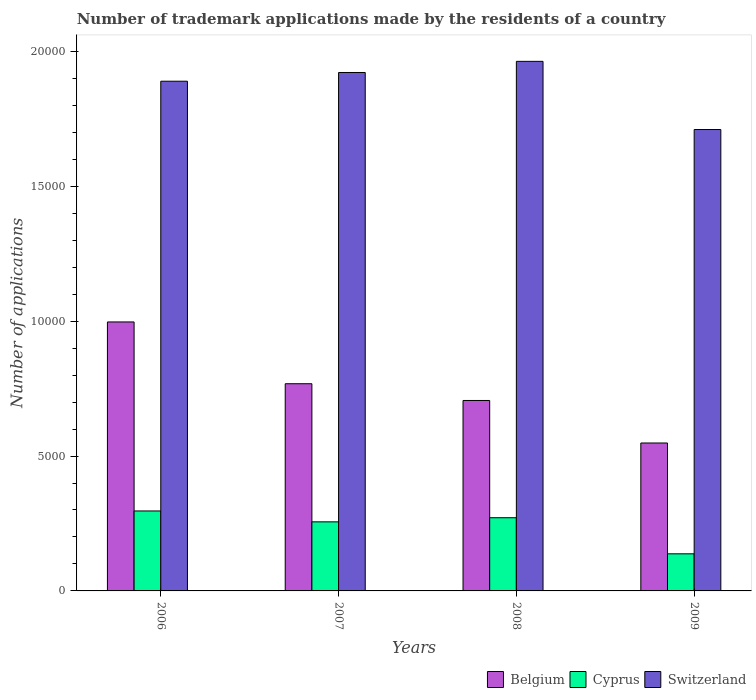How many groups of bars are there?
Your answer should be compact. 4. What is the label of the 2nd group of bars from the left?
Your answer should be compact. 2007. In how many cases, is the number of bars for a given year not equal to the number of legend labels?
Your response must be concise. 0. What is the number of trademark applications made by the residents in Switzerland in 2006?
Offer a very short reply. 1.89e+04. Across all years, what is the maximum number of trademark applications made by the residents in Cyprus?
Keep it short and to the point. 2964. Across all years, what is the minimum number of trademark applications made by the residents in Cyprus?
Give a very brief answer. 1375. What is the total number of trademark applications made by the residents in Switzerland in the graph?
Your answer should be compact. 7.48e+04. What is the difference between the number of trademark applications made by the residents in Belgium in 2008 and that in 2009?
Offer a very short reply. 1576. What is the difference between the number of trademark applications made by the residents in Cyprus in 2008 and the number of trademark applications made by the residents in Switzerland in 2006?
Your answer should be very brief. -1.62e+04. What is the average number of trademark applications made by the residents in Cyprus per year?
Keep it short and to the point. 2403. In the year 2006, what is the difference between the number of trademark applications made by the residents in Cyprus and number of trademark applications made by the residents in Belgium?
Offer a terse response. -7006. In how many years, is the number of trademark applications made by the residents in Switzerland greater than 7000?
Provide a succinct answer. 4. What is the ratio of the number of trademark applications made by the residents in Switzerland in 2006 to that in 2007?
Your answer should be very brief. 0.98. Is the number of trademark applications made by the residents in Switzerland in 2008 less than that in 2009?
Your answer should be compact. No. Is the difference between the number of trademark applications made by the residents in Cyprus in 2008 and 2009 greater than the difference between the number of trademark applications made by the residents in Belgium in 2008 and 2009?
Make the answer very short. No. What is the difference between the highest and the second highest number of trademark applications made by the residents in Belgium?
Give a very brief answer. 2290. What is the difference between the highest and the lowest number of trademark applications made by the residents in Switzerland?
Provide a short and direct response. 2527. Is the sum of the number of trademark applications made by the residents in Switzerland in 2008 and 2009 greater than the maximum number of trademark applications made by the residents in Cyprus across all years?
Offer a very short reply. Yes. What does the 2nd bar from the left in 2009 represents?
Offer a terse response. Cyprus. Is it the case that in every year, the sum of the number of trademark applications made by the residents in Switzerland and number of trademark applications made by the residents in Cyprus is greater than the number of trademark applications made by the residents in Belgium?
Offer a terse response. Yes. How many bars are there?
Provide a short and direct response. 12. Are all the bars in the graph horizontal?
Provide a short and direct response. No. What is the difference between two consecutive major ticks on the Y-axis?
Keep it short and to the point. 5000. Does the graph contain any zero values?
Offer a terse response. No. Where does the legend appear in the graph?
Keep it short and to the point. Bottom right. What is the title of the graph?
Give a very brief answer. Number of trademark applications made by the residents of a country. What is the label or title of the Y-axis?
Ensure brevity in your answer.  Number of applications. What is the Number of applications of Belgium in 2006?
Keep it short and to the point. 9970. What is the Number of applications in Cyprus in 2006?
Ensure brevity in your answer.  2964. What is the Number of applications of Switzerland in 2006?
Ensure brevity in your answer.  1.89e+04. What is the Number of applications in Belgium in 2007?
Make the answer very short. 7680. What is the Number of applications in Cyprus in 2007?
Your response must be concise. 2560. What is the Number of applications of Switzerland in 2007?
Ensure brevity in your answer.  1.92e+04. What is the Number of applications of Belgium in 2008?
Make the answer very short. 7059. What is the Number of applications of Cyprus in 2008?
Offer a terse response. 2713. What is the Number of applications in Switzerland in 2008?
Provide a succinct answer. 1.96e+04. What is the Number of applications of Belgium in 2009?
Your response must be concise. 5483. What is the Number of applications in Cyprus in 2009?
Offer a very short reply. 1375. What is the Number of applications of Switzerland in 2009?
Offer a terse response. 1.71e+04. Across all years, what is the maximum Number of applications of Belgium?
Your answer should be very brief. 9970. Across all years, what is the maximum Number of applications of Cyprus?
Give a very brief answer. 2964. Across all years, what is the maximum Number of applications of Switzerland?
Ensure brevity in your answer.  1.96e+04. Across all years, what is the minimum Number of applications in Belgium?
Ensure brevity in your answer.  5483. Across all years, what is the minimum Number of applications in Cyprus?
Offer a terse response. 1375. Across all years, what is the minimum Number of applications in Switzerland?
Make the answer very short. 1.71e+04. What is the total Number of applications in Belgium in the graph?
Your answer should be very brief. 3.02e+04. What is the total Number of applications in Cyprus in the graph?
Ensure brevity in your answer.  9612. What is the total Number of applications in Switzerland in the graph?
Provide a succinct answer. 7.48e+04. What is the difference between the Number of applications in Belgium in 2006 and that in 2007?
Ensure brevity in your answer.  2290. What is the difference between the Number of applications of Cyprus in 2006 and that in 2007?
Keep it short and to the point. 404. What is the difference between the Number of applications in Switzerland in 2006 and that in 2007?
Provide a succinct answer. -323. What is the difference between the Number of applications in Belgium in 2006 and that in 2008?
Your answer should be very brief. 2911. What is the difference between the Number of applications in Cyprus in 2006 and that in 2008?
Offer a very short reply. 251. What is the difference between the Number of applications of Switzerland in 2006 and that in 2008?
Offer a terse response. -736. What is the difference between the Number of applications of Belgium in 2006 and that in 2009?
Provide a succinct answer. 4487. What is the difference between the Number of applications of Cyprus in 2006 and that in 2009?
Ensure brevity in your answer.  1589. What is the difference between the Number of applications of Switzerland in 2006 and that in 2009?
Offer a very short reply. 1791. What is the difference between the Number of applications of Belgium in 2007 and that in 2008?
Provide a succinct answer. 621. What is the difference between the Number of applications in Cyprus in 2007 and that in 2008?
Ensure brevity in your answer.  -153. What is the difference between the Number of applications in Switzerland in 2007 and that in 2008?
Make the answer very short. -413. What is the difference between the Number of applications in Belgium in 2007 and that in 2009?
Give a very brief answer. 2197. What is the difference between the Number of applications in Cyprus in 2007 and that in 2009?
Your response must be concise. 1185. What is the difference between the Number of applications in Switzerland in 2007 and that in 2009?
Offer a terse response. 2114. What is the difference between the Number of applications of Belgium in 2008 and that in 2009?
Provide a short and direct response. 1576. What is the difference between the Number of applications of Cyprus in 2008 and that in 2009?
Your response must be concise. 1338. What is the difference between the Number of applications in Switzerland in 2008 and that in 2009?
Your response must be concise. 2527. What is the difference between the Number of applications of Belgium in 2006 and the Number of applications of Cyprus in 2007?
Your answer should be very brief. 7410. What is the difference between the Number of applications in Belgium in 2006 and the Number of applications in Switzerland in 2007?
Offer a very short reply. -9246. What is the difference between the Number of applications in Cyprus in 2006 and the Number of applications in Switzerland in 2007?
Your answer should be very brief. -1.63e+04. What is the difference between the Number of applications in Belgium in 2006 and the Number of applications in Cyprus in 2008?
Keep it short and to the point. 7257. What is the difference between the Number of applications in Belgium in 2006 and the Number of applications in Switzerland in 2008?
Keep it short and to the point. -9659. What is the difference between the Number of applications of Cyprus in 2006 and the Number of applications of Switzerland in 2008?
Offer a very short reply. -1.67e+04. What is the difference between the Number of applications in Belgium in 2006 and the Number of applications in Cyprus in 2009?
Your answer should be compact. 8595. What is the difference between the Number of applications of Belgium in 2006 and the Number of applications of Switzerland in 2009?
Offer a terse response. -7132. What is the difference between the Number of applications in Cyprus in 2006 and the Number of applications in Switzerland in 2009?
Offer a very short reply. -1.41e+04. What is the difference between the Number of applications of Belgium in 2007 and the Number of applications of Cyprus in 2008?
Your answer should be compact. 4967. What is the difference between the Number of applications in Belgium in 2007 and the Number of applications in Switzerland in 2008?
Make the answer very short. -1.19e+04. What is the difference between the Number of applications of Cyprus in 2007 and the Number of applications of Switzerland in 2008?
Keep it short and to the point. -1.71e+04. What is the difference between the Number of applications in Belgium in 2007 and the Number of applications in Cyprus in 2009?
Make the answer very short. 6305. What is the difference between the Number of applications of Belgium in 2007 and the Number of applications of Switzerland in 2009?
Provide a succinct answer. -9422. What is the difference between the Number of applications of Cyprus in 2007 and the Number of applications of Switzerland in 2009?
Your answer should be compact. -1.45e+04. What is the difference between the Number of applications in Belgium in 2008 and the Number of applications in Cyprus in 2009?
Give a very brief answer. 5684. What is the difference between the Number of applications in Belgium in 2008 and the Number of applications in Switzerland in 2009?
Offer a very short reply. -1.00e+04. What is the difference between the Number of applications in Cyprus in 2008 and the Number of applications in Switzerland in 2009?
Offer a very short reply. -1.44e+04. What is the average Number of applications of Belgium per year?
Your response must be concise. 7548. What is the average Number of applications of Cyprus per year?
Provide a succinct answer. 2403. What is the average Number of applications of Switzerland per year?
Your response must be concise. 1.87e+04. In the year 2006, what is the difference between the Number of applications of Belgium and Number of applications of Cyprus?
Offer a very short reply. 7006. In the year 2006, what is the difference between the Number of applications in Belgium and Number of applications in Switzerland?
Give a very brief answer. -8923. In the year 2006, what is the difference between the Number of applications of Cyprus and Number of applications of Switzerland?
Provide a short and direct response. -1.59e+04. In the year 2007, what is the difference between the Number of applications in Belgium and Number of applications in Cyprus?
Your response must be concise. 5120. In the year 2007, what is the difference between the Number of applications of Belgium and Number of applications of Switzerland?
Your response must be concise. -1.15e+04. In the year 2007, what is the difference between the Number of applications of Cyprus and Number of applications of Switzerland?
Your response must be concise. -1.67e+04. In the year 2008, what is the difference between the Number of applications of Belgium and Number of applications of Cyprus?
Your answer should be compact. 4346. In the year 2008, what is the difference between the Number of applications in Belgium and Number of applications in Switzerland?
Ensure brevity in your answer.  -1.26e+04. In the year 2008, what is the difference between the Number of applications of Cyprus and Number of applications of Switzerland?
Your answer should be very brief. -1.69e+04. In the year 2009, what is the difference between the Number of applications in Belgium and Number of applications in Cyprus?
Ensure brevity in your answer.  4108. In the year 2009, what is the difference between the Number of applications of Belgium and Number of applications of Switzerland?
Give a very brief answer. -1.16e+04. In the year 2009, what is the difference between the Number of applications in Cyprus and Number of applications in Switzerland?
Your answer should be compact. -1.57e+04. What is the ratio of the Number of applications of Belgium in 2006 to that in 2007?
Your answer should be very brief. 1.3. What is the ratio of the Number of applications of Cyprus in 2006 to that in 2007?
Offer a very short reply. 1.16. What is the ratio of the Number of applications of Switzerland in 2006 to that in 2007?
Your answer should be very brief. 0.98. What is the ratio of the Number of applications of Belgium in 2006 to that in 2008?
Provide a succinct answer. 1.41. What is the ratio of the Number of applications in Cyprus in 2006 to that in 2008?
Keep it short and to the point. 1.09. What is the ratio of the Number of applications in Switzerland in 2006 to that in 2008?
Your answer should be compact. 0.96. What is the ratio of the Number of applications of Belgium in 2006 to that in 2009?
Ensure brevity in your answer.  1.82. What is the ratio of the Number of applications of Cyprus in 2006 to that in 2009?
Offer a very short reply. 2.16. What is the ratio of the Number of applications of Switzerland in 2006 to that in 2009?
Keep it short and to the point. 1.1. What is the ratio of the Number of applications of Belgium in 2007 to that in 2008?
Your answer should be compact. 1.09. What is the ratio of the Number of applications of Cyprus in 2007 to that in 2008?
Make the answer very short. 0.94. What is the ratio of the Number of applications in Belgium in 2007 to that in 2009?
Your answer should be compact. 1.4. What is the ratio of the Number of applications in Cyprus in 2007 to that in 2009?
Offer a terse response. 1.86. What is the ratio of the Number of applications in Switzerland in 2007 to that in 2009?
Give a very brief answer. 1.12. What is the ratio of the Number of applications of Belgium in 2008 to that in 2009?
Offer a very short reply. 1.29. What is the ratio of the Number of applications of Cyprus in 2008 to that in 2009?
Your answer should be very brief. 1.97. What is the ratio of the Number of applications of Switzerland in 2008 to that in 2009?
Your response must be concise. 1.15. What is the difference between the highest and the second highest Number of applications of Belgium?
Give a very brief answer. 2290. What is the difference between the highest and the second highest Number of applications of Cyprus?
Your answer should be very brief. 251. What is the difference between the highest and the second highest Number of applications of Switzerland?
Offer a very short reply. 413. What is the difference between the highest and the lowest Number of applications of Belgium?
Keep it short and to the point. 4487. What is the difference between the highest and the lowest Number of applications of Cyprus?
Your response must be concise. 1589. What is the difference between the highest and the lowest Number of applications in Switzerland?
Make the answer very short. 2527. 